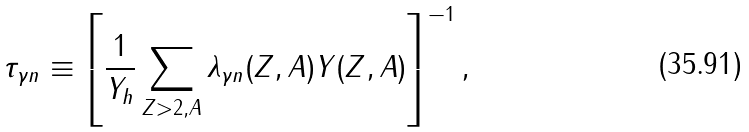<formula> <loc_0><loc_0><loc_500><loc_500>\tau _ { \gamma n } \equiv \left [ \frac { 1 } { Y _ { h } } \sum _ { Z > 2 , A } \lambda _ { \gamma n } ( Z , A ) Y ( Z , A ) \right ] ^ { - 1 } ,</formula> 